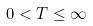Convert formula to latex. <formula><loc_0><loc_0><loc_500><loc_500>0 < T \leq \infty</formula> 